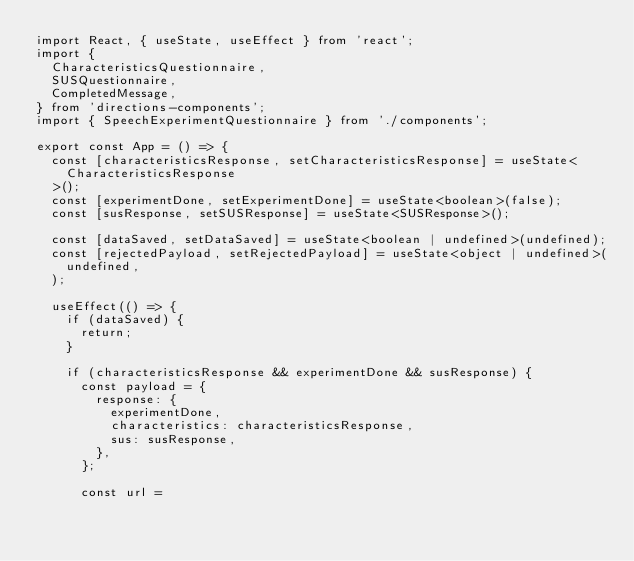Convert code to text. <code><loc_0><loc_0><loc_500><loc_500><_TypeScript_>import React, { useState, useEffect } from 'react';
import {
  CharacteristicsQuestionnaire,
  SUSQuestionnaire,
  CompletedMessage,
} from 'directions-components';
import { SpeechExperimentQuestionnaire } from './components';

export const App = () => {
  const [characteristicsResponse, setCharacteristicsResponse] = useState<
    CharacteristicsResponse
  >();
  const [experimentDone, setExperimentDone] = useState<boolean>(false);
  const [susResponse, setSUSResponse] = useState<SUSResponse>();

  const [dataSaved, setDataSaved] = useState<boolean | undefined>(undefined);
  const [rejectedPayload, setRejectedPayload] = useState<object | undefined>(
    undefined,
  );

  useEffect(() => {
    if (dataSaved) {
      return;
    }

    if (characteristicsResponse && experimentDone && susResponse) {
      const payload = {
        response: {
          experimentDone,
          characteristics: characteristicsResponse,
          sus: susResponse,
        },
      };

      const url =</code> 